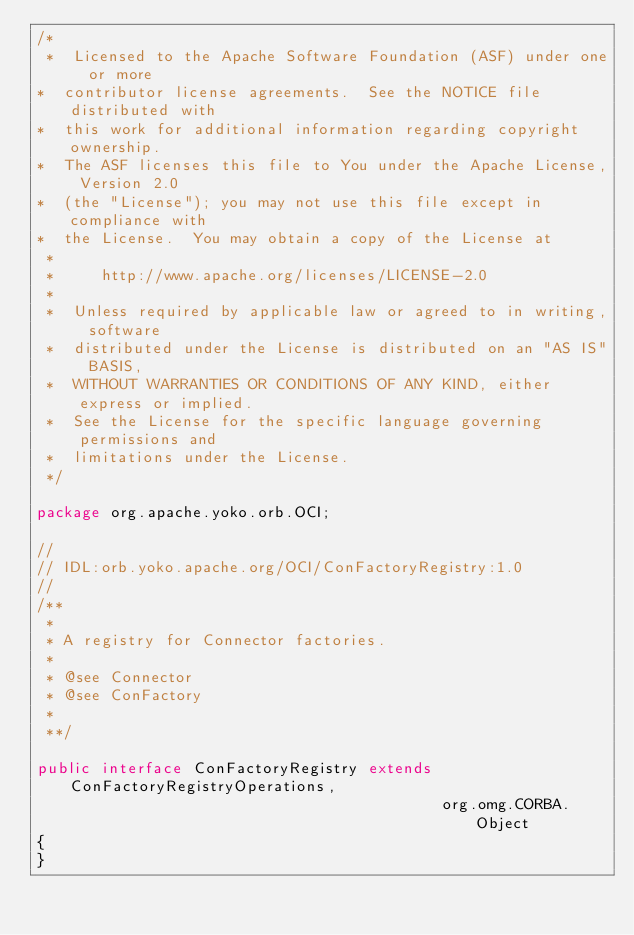<code> <loc_0><loc_0><loc_500><loc_500><_Java_>/*
 *  Licensed to the Apache Software Foundation (ASF) under one or more
*  contributor license agreements.  See the NOTICE file distributed with
*  this work for additional information regarding copyright ownership.
*  The ASF licenses this file to You under the Apache License, Version 2.0
*  (the "License"); you may not use this file except in compliance with
*  the License.  You may obtain a copy of the License at
 *
 *     http://www.apache.org/licenses/LICENSE-2.0
 *
 *  Unless required by applicable law or agreed to in writing, software
 *  distributed under the License is distributed on an "AS IS" BASIS,
 *  WITHOUT WARRANTIES OR CONDITIONS OF ANY KIND, either express or implied.
 *  See the License for the specific language governing permissions and
 *  limitations under the License.
 */

package org.apache.yoko.orb.OCI;

//
// IDL:orb.yoko.apache.org/OCI/ConFactoryRegistry:1.0
//
/**
 *
 * A registry for Connector factories.
 *
 * @see Connector
 * @see ConFactory
 *
 **/

public interface ConFactoryRegistry extends ConFactoryRegistryOperations,
                                            org.omg.CORBA.Object
{
}
</code> 